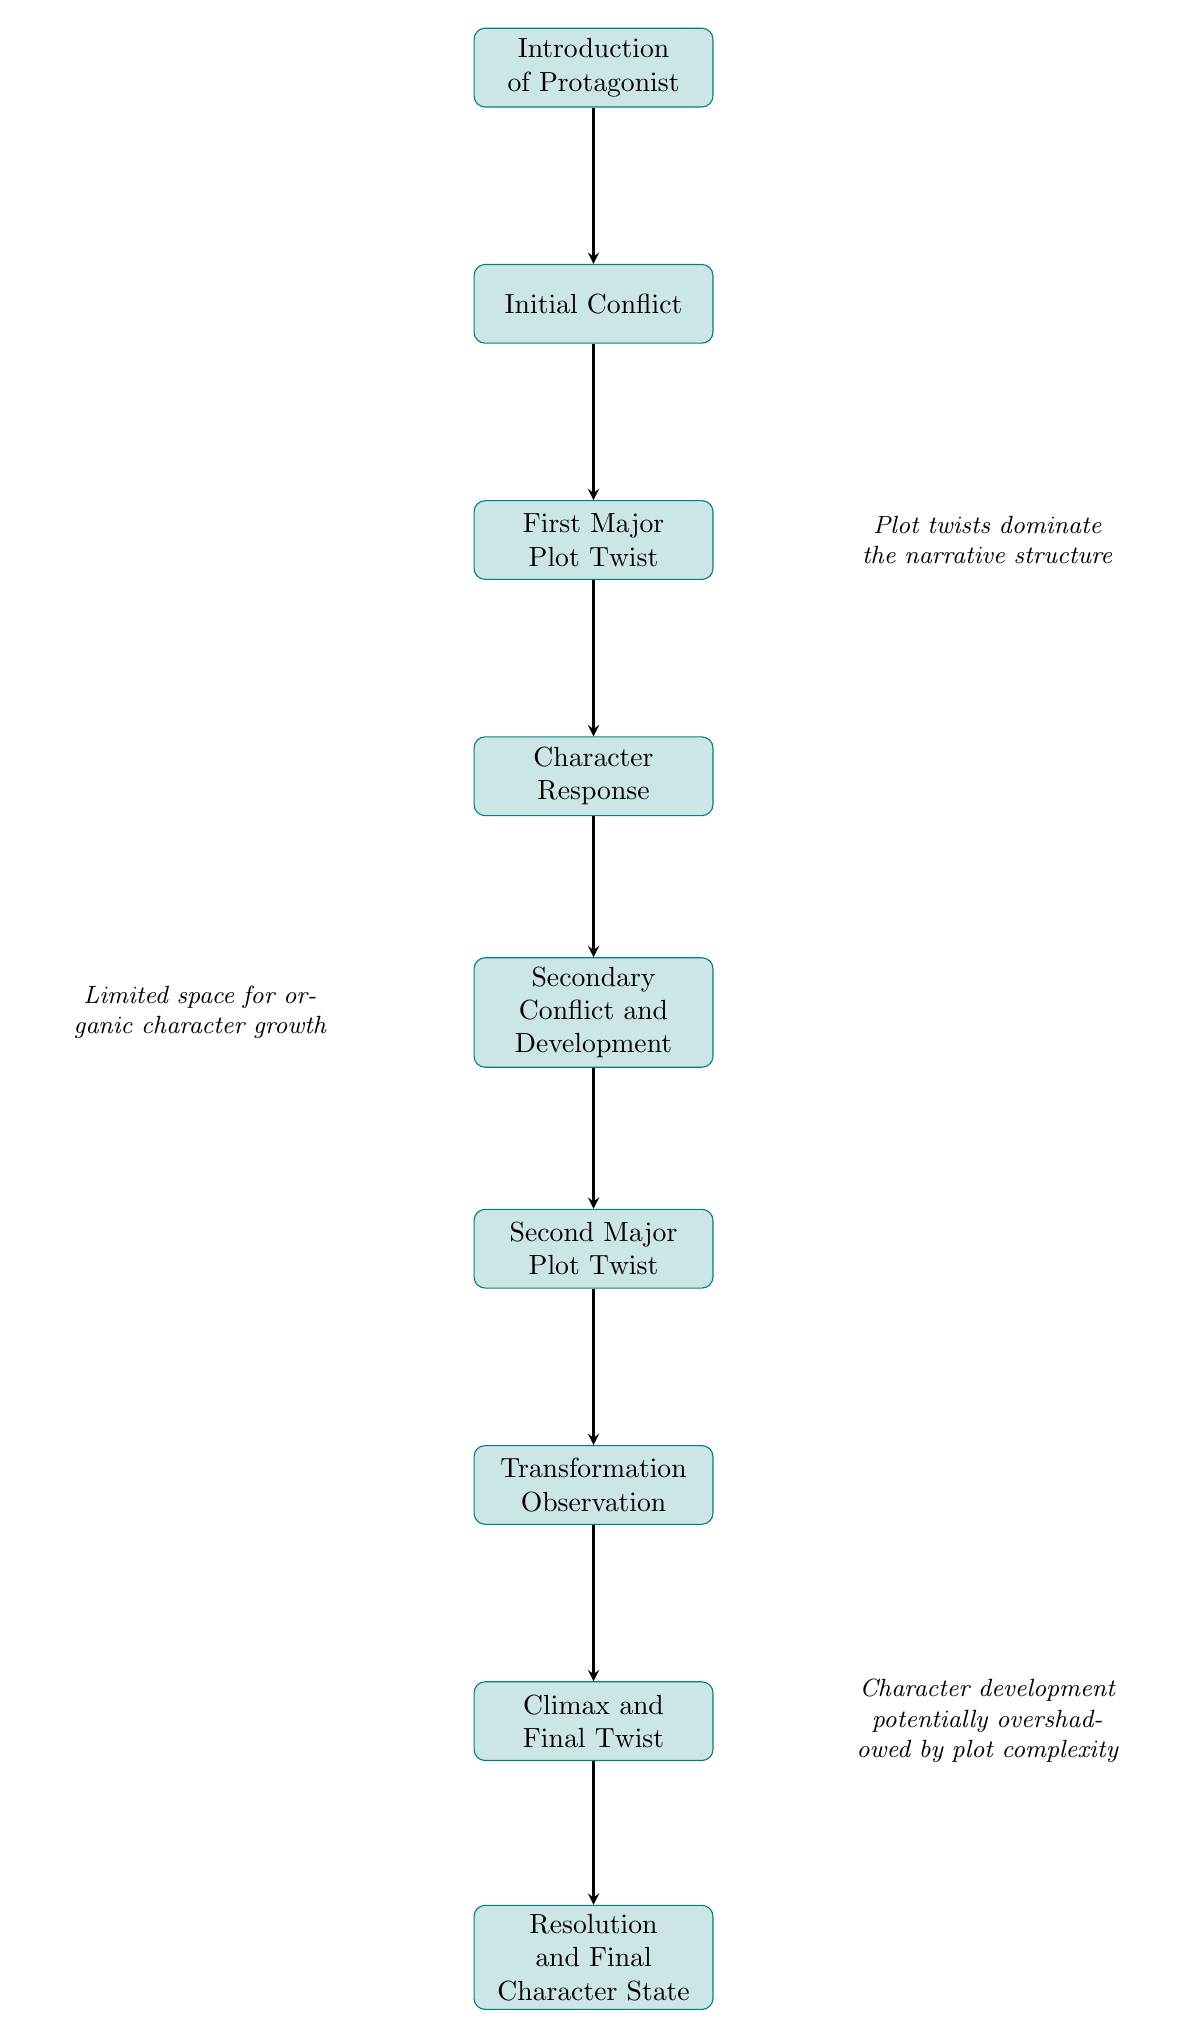What is the starting point in the character arc? The character arc begins at the "Introduction of Protagonist" node, which signifies where the main character is first presented.
Answer: Introduction of Protagonist How many major plot twists are depicted in the diagram? The diagram illustrates two major plot twists which are specified as "First Major Plot Twist" and "Second Major Plot Twist."
Answer: 2 What comes immediately after "Character Response"? Following "Character Response," the next node in the flow is "Secondary Conflict and Development," showing the progression of the character's journey.
Answer: Secondary Conflict and Development Which node evaluates the protagonist's change throughout the narrative? The "Transformation Observation" node is where the changes in the protagonist's character due to the plot twists are assessed, indicating an analysis of their development.
Answer: Transformation Observation What is emphasized by the additional text on the right of "First Major Plot Twist"? The accompanying text states that "Plot twists dominate the narrative structure," emphasizing the significant role that plot twists play in shaping the storyline.
Answer: Plot twists dominate the narrative structure Which node indicates the story's conclusion? The last node in the diagram, "Resolution and Final Character State," signifies the conclusion of the storyline and reflects on the protagonist’s growth or lack thereof.
Answer: Resolution and Final Character State What relationship exists between "Initial Conflict" and "First Major Plot Twist"? The flow from "Initial Conflict" to "First Major Plot Twist" indicates that the initial conflict leads to a significant turning point in the story, marking the progression of the narrative.
Answer: Leads to How do plot twists affect character development according to the diagram? The diagram suggests that "Character development potentially overshadowed by plot complexity," indicating that the focus on twists can detract from organic character growth.
Answer: Overshadowed by plot complexity What node follows the "Climax and Final Twist"? The subsequent node after "Climax and Final Twist" is "Resolution and Final Character State," which concludes the arc and evaluates the character's development at the end of the story.
Answer: Resolution and Final Character State 